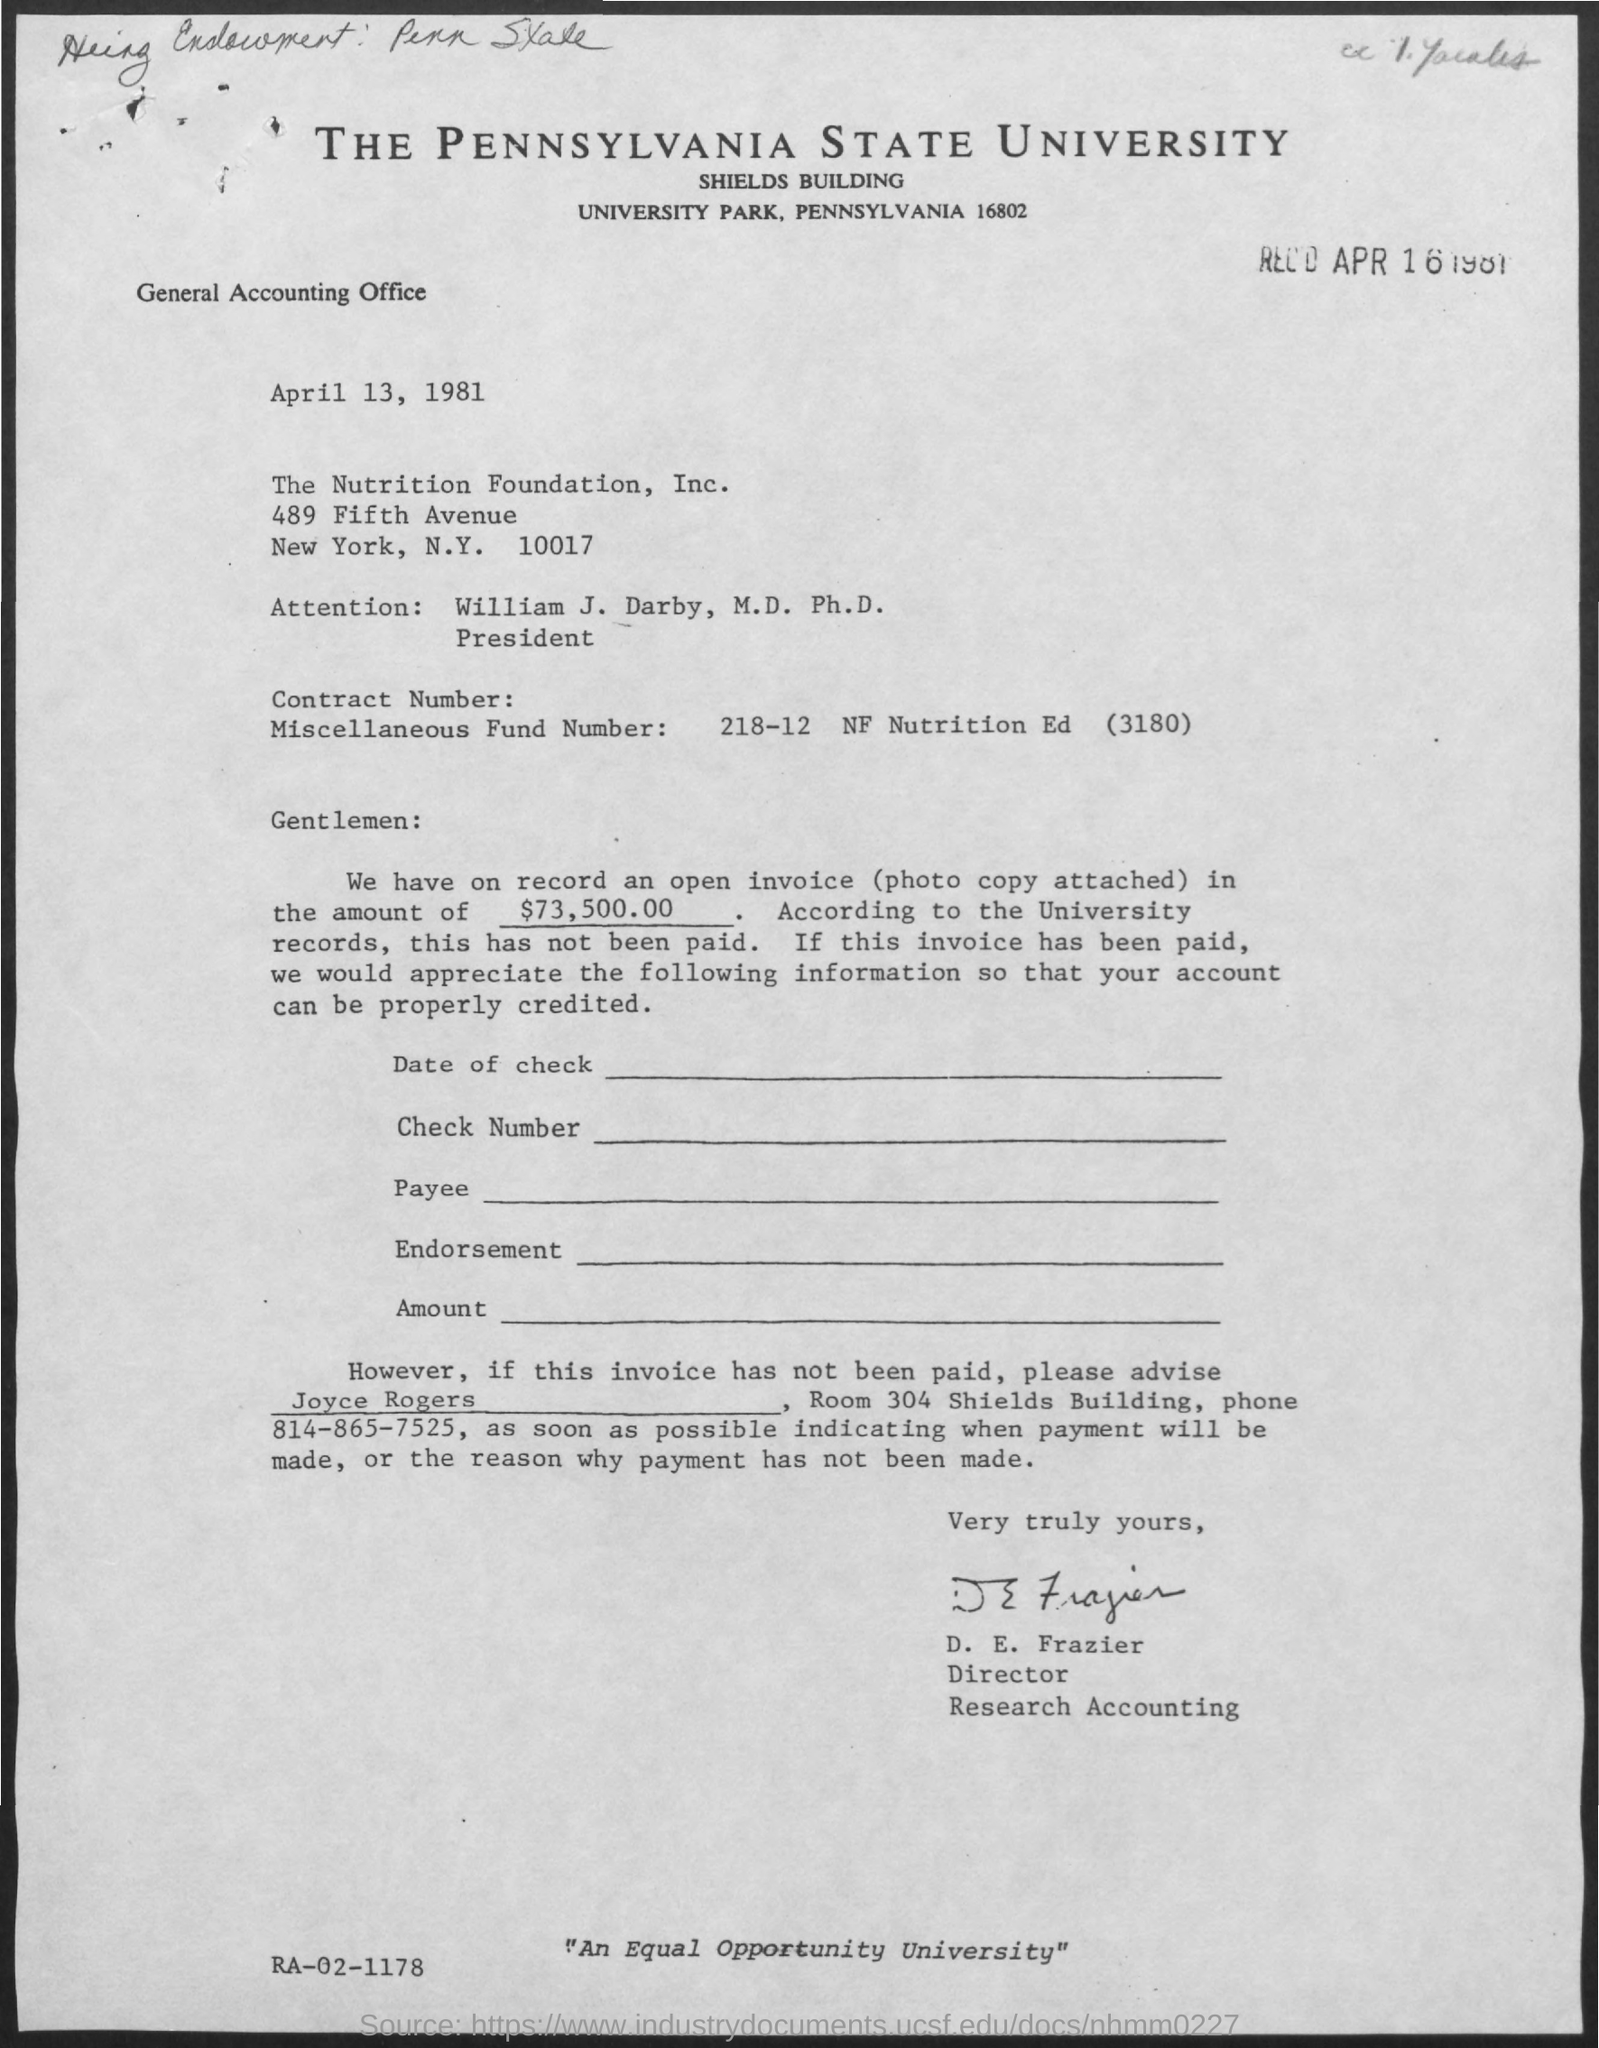Mention a couple of crucial points in this snapshot. The Pennsylvania State University is the title of the document. 